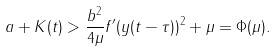Convert formula to latex. <formula><loc_0><loc_0><loc_500><loc_500>a + K ( t ) > \frac { b ^ { 2 } } { 4 \mu } f ^ { \prime } ( y ( t - \tau ) ) ^ { 2 } + \mu = \Phi ( \mu ) .</formula> 